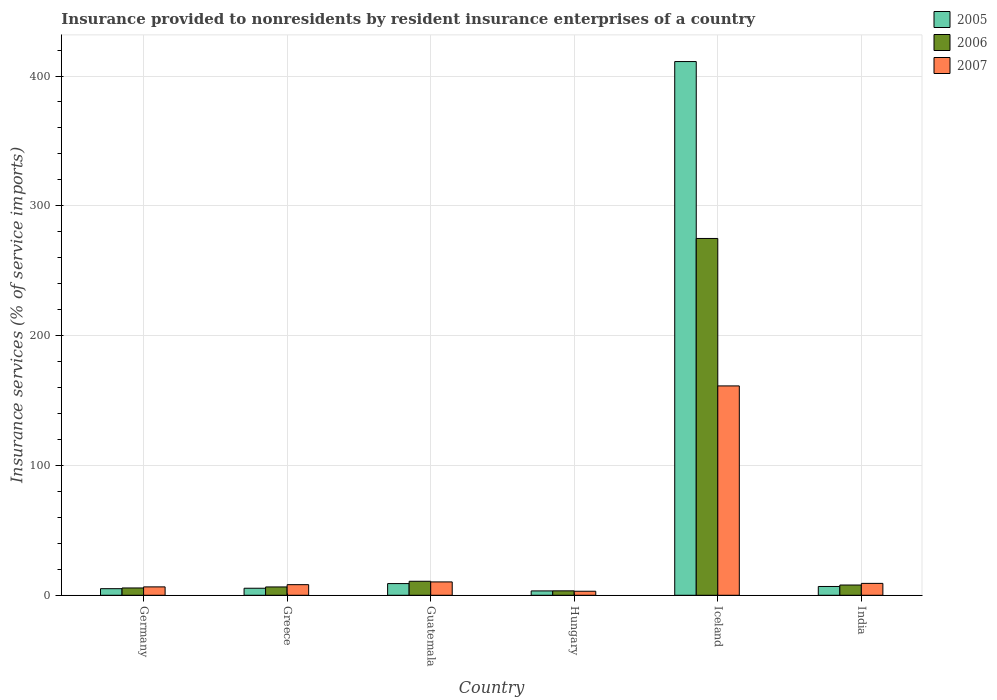Are the number of bars on each tick of the X-axis equal?
Ensure brevity in your answer.  Yes. In how many cases, is the number of bars for a given country not equal to the number of legend labels?
Your response must be concise. 0. What is the insurance provided to nonresidents in 2007 in Guatemala?
Keep it short and to the point. 10.29. Across all countries, what is the maximum insurance provided to nonresidents in 2007?
Provide a short and direct response. 161.27. Across all countries, what is the minimum insurance provided to nonresidents in 2006?
Offer a terse response. 3.4. In which country was the insurance provided to nonresidents in 2006 maximum?
Keep it short and to the point. Iceland. In which country was the insurance provided to nonresidents in 2005 minimum?
Provide a short and direct response. Hungary. What is the total insurance provided to nonresidents in 2005 in the graph?
Your answer should be very brief. 440.79. What is the difference between the insurance provided to nonresidents in 2007 in Greece and that in Iceland?
Make the answer very short. -153.1. What is the difference between the insurance provided to nonresidents in 2005 in India and the insurance provided to nonresidents in 2006 in Greece?
Your answer should be compact. 0.36. What is the average insurance provided to nonresidents in 2007 per country?
Offer a terse response. 33.08. What is the difference between the insurance provided to nonresidents of/in 2005 and insurance provided to nonresidents of/in 2006 in Guatemala?
Offer a very short reply. -1.78. What is the ratio of the insurance provided to nonresidents in 2006 in Iceland to that in India?
Your response must be concise. 34.8. What is the difference between the highest and the second highest insurance provided to nonresidents in 2006?
Your response must be concise. 264.08. What is the difference between the highest and the lowest insurance provided to nonresidents in 2007?
Ensure brevity in your answer.  158.16. In how many countries, is the insurance provided to nonresidents in 2006 greater than the average insurance provided to nonresidents in 2006 taken over all countries?
Offer a very short reply. 1. Is the sum of the insurance provided to nonresidents in 2005 in Iceland and India greater than the maximum insurance provided to nonresidents in 2007 across all countries?
Offer a very short reply. Yes. What does the 3rd bar from the left in Greece represents?
Your answer should be very brief. 2007. Is it the case that in every country, the sum of the insurance provided to nonresidents in 2006 and insurance provided to nonresidents in 2005 is greater than the insurance provided to nonresidents in 2007?
Provide a succinct answer. Yes. How many bars are there?
Your answer should be compact. 18. How many countries are there in the graph?
Keep it short and to the point. 6. Are the values on the major ticks of Y-axis written in scientific E-notation?
Offer a terse response. No. Does the graph contain grids?
Ensure brevity in your answer.  Yes. Where does the legend appear in the graph?
Offer a very short reply. Top right. How many legend labels are there?
Give a very brief answer. 3. What is the title of the graph?
Give a very brief answer. Insurance provided to nonresidents by resident insurance enterprises of a country. Does "1999" appear as one of the legend labels in the graph?
Give a very brief answer. No. What is the label or title of the X-axis?
Offer a terse response. Country. What is the label or title of the Y-axis?
Provide a succinct answer. Insurance services (% of service imports). What is the Insurance services (% of service imports) in 2005 in Germany?
Make the answer very short. 5.08. What is the Insurance services (% of service imports) of 2006 in Germany?
Offer a terse response. 5.63. What is the Insurance services (% of service imports) of 2007 in Germany?
Give a very brief answer. 6.47. What is the Insurance services (% of service imports) of 2005 in Greece?
Provide a succinct answer. 5.42. What is the Insurance services (% of service imports) in 2006 in Greece?
Give a very brief answer. 6.42. What is the Insurance services (% of service imports) in 2007 in Greece?
Your response must be concise. 8.17. What is the Insurance services (% of service imports) in 2005 in Guatemala?
Ensure brevity in your answer.  9.01. What is the Insurance services (% of service imports) in 2006 in Guatemala?
Give a very brief answer. 10.78. What is the Insurance services (% of service imports) of 2007 in Guatemala?
Offer a very short reply. 10.29. What is the Insurance services (% of service imports) of 2005 in Hungary?
Your response must be concise. 3.36. What is the Insurance services (% of service imports) of 2006 in Hungary?
Keep it short and to the point. 3.4. What is the Insurance services (% of service imports) in 2007 in Hungary?
Your response must be concise. 3.11. What is the Insurance services (% of service imports) of 2005 in Iceland?
Your answer should be compact. 411.14. What is the Insurance services (% of service imports) in 2006 in Iceland?
Your answer should be compact. 274.86. What is the Insurance services (% of service imports) in 2007 in Iceland?
Keep it short and to the point. 161.27. What is the Insurance services (% of service imports) in 2005 in India?
Your response must be concise. 6.78. What is the Insurance services (% of service imports) in 2006 in India?
Your answer should be very brief. 7.9. What is the Insurance services (% of service imports) of 2007 in India?
Keep it short and to the point. 9.16. Across all countries, what is the maximum Insurance services (% of service imports) of 2005?
Give a very brief answer. 411.14. Across all countries, what is the maximum Insurance services (% of service imports) in 2006?
Provide a short and direct response. 274.86. Across all countries, what is the maximum Insurance services (% of service imports) of 2007?
Offer a terse response. 161.27. Across all countries, what is the minimum Insurance services (% of service imports) in 2005?
Your response must be concise. 3.36. Across all countries, what is the minimum Insurance services (% of service imports) of 2006?
Provide a succinct answer. 3.4. Across all countries, what is the minimum Insurance services (% of service imports) in 2007?
Make the answer very short. 3.11. What is the total Insurance services (% of service imports) in 2005 in the graph?
Ensure brevity in your answer.  440.79. What is the total Insurance services (% of service imports) in 2006 in the graph?
Ensure brevity in your answer.  309. What is the total Insurance services (% of service imports) of 2007 in the graph?
Keep it short and to the point. 198.47. What is the difference between the Insurance services (% of service imports) in 2005 in Germany and that in Greece?
Give a very brief answer. -0.34. What is the difference between the Insurance services (% of service imports) in 2006 in Germany and that in Greece?
Provide a short and direct response. -0.79. What is the difference between the Insurance services (% of service imports) in 2007 in Germany and that in Greece?
Provide a short and direct response. -1.71. What is the difference between the Insurance services (% of service imports) of 2005 in Germany and that in Guatemala?
Your response must be concise. -3.93. What is the difference between the Insurance services (% of service imports) in 2006 in Germany and that in Guatemala?
Provide a succinct answer. -5.16. What is the difference between the Insurance services (% of service imports) of 2007 in Germany and that in Guatemala?
Offer a very short reply. -3.82. What is the difference between the Insurance services (% of service imports) of 2005 in Germany and that in Hungary?
Keep it short and to the point. 1.72. What is the difference between the Insurance services (% of service imports) of 2006 in Germany and that in Hungary?
Offer a terse response. 2.22. What is the difference between the Insurance services (% of service imports) of 2007 in Germany and that in Hungary?
Offer a very short reply. 3.36. What is the difference between the Insurance services (% of service imports) of 2005 in Germany and that in Iceland?
Provide a succinct answer. -406.05. What is the difference between the Insurance services (% of service imports) of 2006 in Germany and that in Iceland?
Make the answer very short. -269.23. What is the difference between the Insurance services (% of service imports) of 2007 in Germany and that in Iceland?
Your answer should be very brief. -154.8. What is the difference between the Insurance services (% of service imports) of 2005 in Germany and that in India?
Your response must be concise. -1.7. What is the difference between the Insurance services (% of service imports) of 2006 in Germany and that in India?
Your response must be concise. -2.27. What is the difference between the Insurance services (% of service imports) in 2007 in Germany and that in India?
Your answer should be compact. -2.69. What is the difference between the Insurance services (% of service imports) in 2005 in Greece and that in Guatemala?
Offer a terse response. -3.59. What is the difference between the Insurance services (% of service imports) in 2006 in Greece and that in Guatemala?
Provide a succinct answer. -4.36. What is the difference between the Insurance services (% of service imports) in 2007 in Greece and that in Guatemala?
Provide a short and direct response. -2.11. What is the difference between the Insurance services (% of service imports) of 2005 in Greece and that in Hungary?
Your response must be concise. 2.06. What is the difference between the Insurance services (% of service imports) in 2006 in Greece and that in Hungary?
Keep it short and to the point. 3.02. What is the difference between the Insurance services (% of service imports) in 2007 in Greece and that in Hungary?
Offer a very short reply. 5.06. What is the difference between the Insurance services (% of service imports) of 2005 in Greece and that in Iceland?
Your answer should be very brief. -405.72. What is the difference between the Insurance services (% of service imports) in 2006 in Greece and that in Iceland?
Ensure brevity in your answer.  -268.44. What is the difference between the Insurance services (% of service imports) of 2007 in Greece and that in Iceland?
Offer a terse response. -153.1. What is the difference between the Insurance services (% of service imports) in 2005 in Greece and that in India?
Your answer should be compact. -1.36. What is the difference between the Insurance services (% of service imports) in 2006 in Greece and that in India?
Provide a succinct answer. -1.48. What is the difference between the Insurance services (% of service imports) in 2007 in Greece and that in India?
Your answer should be compact. -0.98. What is the difference between the Insurance services (% of service imports) in 2005 in Guatemala and that in Hungary?
Offer a terse response. 5.65. What is the difference between the Insurance services (% of service imports) of 2006 in Guatemala and that in Hungary?
Give a very brief answer. 7.38. What is the difference between the Insurance services (% of service imports) in 2007 in Guatemala and that in Hungary?
Your answer should be compact. 7.18. What is the difference between the Insurance services (% of service imports) of 2005 in Guatemala and that in Iceland?
Give a very brief answer. -402.13. What is the difference between the Insurance services (% of service imports) of 2006 in Guatemala and that in Iceland?
Offer a very short reply. -264.08. What is the difference between the Insurance services (% of service imports) in 2007 in Guatemala and that in Iceland?
Make the answer very short. -150.99. What is the difference between the Insurance services (% of service imports) in 2005 in Guatemala and that in India?
Offer a terse response. 2.23. What is the difference between the Insurance services (% of service imports) in 2006 in Guatemala and that in India?
Provide a short and direct response. 2.89. What is the difference between the Insurance services (% of service imports) in 2007 in Guatemala and that in India?
Your answer should be compact. 1.13. What is the difference between the Insurance services (% of service imports) of 2005 in Hungary and that in Iceland?
Provide a succinct answer. -407.77. What is the difference between the Insurance services (% of service imports) in 2006 in Hungary and that in Iceland?
Ensure brevity in your answer.  -271.46. What is the difference between the Insurance services (% of service imports) of 2007 in Hungary and that in Iceland?
Keep it short and to the point. -158.16. What is the difference between the Insurance services (% of service imports) in 2005 in Hungary and that in India?
Your answer should be compact. -3.42. What is the difference between the Insurance services (% of service imports) in 2006 in Hungary and that in India?
Offer a very short reply. -4.49. What is the difference between the Insurance services (% of service imports) of 2007 in Hungary and that in India?
Ensure brevity in your answer.  -6.05. What is the difference between the Insurance services (% of service imports) in 2005 in Iceland and that in India?
Make the answer very short. 404.35. What is the difference between the Insurance services (% of service imports) of 2006 in Iceland and that in India?
Your answer should be very brief. 266.96. What is the difference between the Insurance services (% of service imports) in 2007 in Iceland and that in India?
Your answer should be compact. 152.12. What is the difference between the Insurance services (% of service imports) of 2005 in Germany and the Insurance services (% of service imports) of 2006 in Greece?
Provide a short and direct response. -1.34. What is the difference between the Insurance services (% of service imports) of 2005 in Germany and the Insurance services (% of service imports) of 2007 in Greece?
Provide a succinct answer. -3.09. What is the difference between the Insurance services (% of service imports) in 2006 in Germany and the Insurance services (% of service imports) in 2007 in Greece?
Keep it short and to the point. -2.54. What is the difference between the Insurance services (% of service imports) of 2005 in Germany and the Insurance services (% of service imports) of 2006 in Guatemala?
Provide a short and direct response. -5.7. What is the difference between the Insurance services (% of service imports) of 2005 in Germany and the Insurance services (% of service imports) of 2007 in Guatemala?
Your answer should be very brief. -5.21. What is the difference between the Insurance services (% of service imports) in 2006 in Germany and the Insurance services (% of service imports) in 2007 in Guatemala?
Your response must be concise. -4.66. What is the difference between the Insurance services (% of service imports) in 2005 in Germany and the Insurance services (% of service imports) in 2006 in Hungary?
Your response must be concise. 1.68. What is the difference between the Insurance services (% of service imports) of 2005 in Germany and the Insurance services (% of service imports) of 2007 in Hungary?
Your response must be concise. 1.97. What is the difference between the Insurance services (% of service imports) of 2006 in Germany and the Insurance services (% of service imports) of 2007 in Hungary?
Provide a short and direct response. 2.52. What is the difference between the Insurance services (% of service imports) of 2005 in Germany and the Insurance services (% of service imports) of 2006 in Iceland?
Keep it short and to the point. -269.78. What is the difference between the Insurance services (% of service imports) of 2005 in Germany and the Insurance services (% of service imports) of 2007 in Iceland?
Offer a terse response. -156.19. What is the difference between the Insurance services (% of service imports) of 2006 in Germany and the Insurance services (% of service imports) of 2007 in Iceland?
Your answer should be compact. -155.64. What is the difference between the Insurance services (% of service imports) of 2005 in Germany and the Insurance services (% of service imports) of 2006 in India?
Keep it short and to the point. -2.81. What is the difference between the Insurance services (% of service imports) in 2005 in Germany and the Insurance services (% of service imports) in 2007 in India?
Your answer should be compact. -4.07. What is the difference between the Insurance services (% of service imports) of 2006 in Germany and the Insurance services (% of service imports) of 2007 in India?
Your response must be concise. -3.53. What is the difference between the Insurance services (% of service imports) in 2005 in Greece and the Insurance services (% of service imports) in 2006 in Guatemala?
Offer a very short reply. -5.37. What is the difference between the Insurance services (% of service imports) in 2005 in Greece and the Insurance services (% of service imports) in 2007 in Guatemala?
Give a very brief answer. -4.87. What is the difference between the Insurance services (% of service imports) in 2006 in Greece and the Insurance services (% of service imports) in 2007 in Guatemala?
Offer a terse response. -3.87. What is the difference between the Insurance services (% of service imports) of 2005 in Greece and the Insurance services (% of service imports) of 2006 in Hungary?
Ensure brevity in your answer.  2.01. What is the difference between the Insurance services (% of service imports) in 2005 in Greece and the Insurance services (% of service imports) in 2007 in Hungary?
Your response must be concise. 2.31. What is the difference between the Insurance services (% of service imports) of 2006 in Greece and the Insurance services (% of service imports) of 2007 in Hungary?
Your response must be concise. 3.31. What is the difference between the Insurance services (% of service imports) of 2005 in Greece and the Insurance services (% of service imports) of 2006 in Iceland?
Your answer should be compact. -269.44. What is the difference between the Insurance services (% of service imports) of 2005 in Greece and the Insurance services (% of service imports) of 2007 in Iceland?
Your answer should be very brief. -155.85. What is the difference between the Insurance services (% of service imports) in 2006 in Greece and the Insurance services (% of service imports) in 2007 in Iceland?
Your response must be concise. -154.85. What is the difference between the Insurance services (% of service imports) of 2005 in Greece and the Insurance services (% of service imports) of 2006 in India?
Offer a very short reply. -2.48. What is the difference between the Insurance services (% of service imports) of 2005 in Greece and the Insurance services (% of service imports) of 2007 in India?
Your answer should be compact. -3.74. What is the difference between the Insurance services (% of service imports) of 2006 in Greece and the Insurance services (% of service imports) of 2007 in India?
Provide a short and direct response. -2.74. What is the difference between the Insurance services (% of service imports) of 2005 in Guatemala and the Insurance services (% of service imports) of 2006 in Hungary?
Your response must be concise. 5.6. What is the difference between the Insurance services (% of service imports) of 2005 in Guatemala and the Insurance services (% of service imports) of 2007 in Hungary?
Provide a succinct answer. 5.9. What is the difference between the Insurance services (% of service imports) in 2006 in Guatemala and the Insurance services (% of service imports) in 2007 in Hungary?
Provide a short and direct response. 7.67. What is the difference between the Insurance services (% of service imports) in 2005 in Guatemala and the Insurance services (% of service imports) in 2006 in Iceland?
Give a very brief answer. -265.85. What is the difference between the Insurance services (% of service imports) of 2005 in Guatemala and the Insurance services (% of service imports) of 2007 in Iceland?
Offer a terse response. -152.26. What is the difference between the Insurance services (% of service imports) in 2006 in Guatemala and the Insurance services (% of service imports) in 2007 in Iceland?
Offer a very short reply. -150.49. What is the difference between the Insurance services (% of service imports) of 2005 in Guatemala and the Insurance services (% of service imports) of 2006 in India?
Your answer should be compact. 1.11. What is the difference between the Insurance services (% of service imports) in 2005 in Guatemala and the Insurance services (% of service imports) in 2007 in India?
Give a very brief answer. -0.15. What is the difference between the Insurance services (% of service imports) in 2006 in Guatemala and the Insurance services (% of service imports) in 2007 in India?
Your answer should be very brief. 1.63. What is the difference between the Insurance services (% of service imports) of 2005 in Hungary and the Insurance services (% of service imports) of 2006 in Iceland?
Provide a succinct answer. -271.5. What is the difference between the Insurance services (% of service imports) in 2005 in Hungary and the Insurance services (% of service imports) in 2007 in Iceland?
Ensure brevity in your answer.  -157.91. What is the difference between the Insurance services (% of service imports) in 2006 in Hungary and the Insurance services (% of service imports) in 2007 in Iceland?
Ensure brevity in your answer.  -157.87. What is the difference between the Insurance services (% of service imports) of 2005 in Hungary and the Insurance services (% of service imports) of 2006 in India?
Provide a succinct answer. -4.54. What is the difference between the Insurance services (% of service imports) of 2005 in Hungary and the Insurance services (% of service imports) of 2007 in India?
Provide a short and direct response. -5.8. What is the difference between the Insurance services (% of service imports) of 2006 in Hungary and the Insurance services (% of service imports) of 2007 in India?
Your answer should be compact. -5.75. What is the difference between the Insurance services (% of service imports) of 2005 in Iceland and the Insurance services (% of service imports) of 2006 in India?
Ensure brevity in your answer.  403.24. What is the difference between the Insurance services (% of service imports) of 2005 in Iceland and the Insurance services (% of service imports) of 2007 in India?
Your response must be concise. 401.98. What is the difference between the Insurance services (% of service imports) of 2006 in Iceland and the Insurance services (% of service imports) of 2007 in India?
Keep it short and to the point. 265.7. What is the average Insurance services (% of service imports) in 2005 per country?
Ensure brevity in your answer.  73.47. What is the average Insurance services (% of service imports) in 2006 per country?
Provide a succinct answer. 51.5. What is the average Insurance services (% of service imports) of 2007 per country?
Your response must be concise. 33.08. What is the difference between the Insurance services (% of service imports) in 2005 and Insurance services (% of service imports) in 2006 in Germany?
Keep it short and to the point. -0.55. What is the difference between the Insurance services (% of service imports) in 2005 and Insurance services (% of service imports) in 2007 in Germany?
Your answer should be very brief. -1.39. What is the difference between the Insurance services (% of service imports) of 2006 and Insurance services (% of service imports) of 2007 in Germany?
Your answer should be compact. -0.84. What is the difference between the Insurance services (% of service imports) in 2005 and Insurance services (% of service imports) in 2006 in Greece?
Your answer should be compact. -1. What is the difference between the Insurance services (% of service imports) in 2005 and Insurance services (% of service imports) in 2007 in Greece?
Your response must be concise. -2.76. What is the difference between the Insurance services (% of service imports) in 2006 and Insurance services (% of service imports) in 2007 in Greece?
Ensure brevity in your answer.  -1.75. What is the difference between the Insurance services (% of service imports) in 2005 and Insurance services (% of service imports) in 2006 in Guatemala?
Make the answer very short. -1.78. What is the difference between the Insurance services (% of service imports) in 2005 and Insurance services (% of service imports) in 2007 in Guatemala?
Your response must be concise. -1.28. What is the difference between the Insurance services (% of service imports) of 2006 and Insurance services (% of service imports) of 2007 in Guatemala?
Your response must be concise. 0.5. What is the difference between the Insurance services (% of service imports) in 2005 and Insurance services (% of service imports) in 2006 in Hungary?
Give a very brief answer. -0.04. What is the difference between the Insurance services (% of service imports) in 2005 and Insurance services (% of service imports) in 2007 in Hungary?
Offer a terse response. 0.25. What is the difference between the Insurance services (% of service imports) of 2006 and Insurance services (% of service imports) of 2007 in Hungary?
Ensure brevity in your answer.  0.29. What is the difference between the Insurance services (% of service imports) in 2005 and Insurance services (% of service imports) in 2006 in Iceland?
Your response must be concise. 136.27. What is the difference between the Insurance services (% of service imports) in 2005 and Insurance services (% of service imports) in 2007 in Iceland?
Offer a terse response. 249.86. What is the difference between the Insurance services (% of service imports) in 2006 and Insurance services (% of service imports) in 2007 in Iceland?
Make the answer very short. 113.59. What is the difference between the Insurance services (% of service imports) in 2005 and Insurance services (% of service imports) in 2006 in India?
Keep it short and to the point. -1.11. What is the difference between the Insurance services (% of service imports) of 2005 and Insurance services (% of service imports) of 2007 in India?
Keep it short and to the point. -2.37. What is the difference between the Insurance services (% of service imports) in 2006 and Insurance services (% of service imports) in 2007 in India?
Your answer should be compact. -1.26. What is the ratio of the Insurance services (% of service imports) of 2005 in Germany to that in Greece?
Offer a terse response. 0.94. What is the ratio of the Insurance services (% of service imports) of 2006 in Germany to that in Greece?
Provide a short and direct response. 0.88. What is the ratio of the Insurance services (% of service imports) in 2007 in Germany to that in Greece?
Provide a short and direct response. 0.79. What is the ratio of the Insurance services (% of service imports) of 2005 in Germany to that in Guatemala?
Provide a short and direct response. 0.56. What is the ratio of the Insurance services (% of service imports) in 2006 in Germany to that in Guatemala?
Provide a succinct answer. 0.52. What is the ratio of the Insurance services (% of service imports) of 2007 in Germany to that in Guatemala?
Provide a succinct answer. 0.63. What is the ratio of the Insurance services (% of service imports) in 2005 in Germany to that in Hungary?
Provide a short and direct response. 1.51. What is the ratio of the Insurance services (% of service imports) of 2006 in Germany to that in Hungary?
Provide a short and direct response. 1.65. What is the ratio of the Insurance services (% of service imports) in 2007 in Germany to that in Hungary?
Ensure brevity in your answer.  2.08. What is the ratio of the Insurance services (% of service imports) in 2005 in Germany to that in Iceland?
Your answer should be compact. 0.01. What is the ratio of the Insurance services (% of service imports) in 2006 in Germany to that in Iceland?
Offer a terse response. 0.02. What is the ratio of the Insurance services (% of service imports) in 2007 in Germany to that in Iceland?
Provide a succinct answer. 0.04. What is the ratio of the Insurance services (% of service imports) in 2005 in Germany to that in India?
Ensure brevity in your answer.  0.75. What is the ratio of the Insurance services (% of service imports) in 2006 in Germany to that in India?
Ensure brevity in your answer.  0.71. What is the ratio of the Insurance services (% of service imports) in 2007 in Germany to that in India?
Provide a short and direct response. 0.71. What is the ratio of the Insurance services (% of service imports) of 2005 in Greece to that in Guatemala?
Provide a succinct answer. 0.6. What is the ratio of the Insurance services (% of service imports) in 2006 in Greece to that in Guatemala?
Give a very brief answer. 0.6. What is the ratio of the Insurance services (% of service imports) of 2007 in Greece to that in Guatemala?
Your response must be concise. 0.79. What is the ratio of the Insurance services (% of service imports) of 2005 in Greece to that in Hungary?
Your answer should be compact. 1.61. What is the ratio of the Insurance services (% of service imports) of 2006 in Greece to that in Hungary?
Ensure brevity in your answer.  1.89. What is the ratio of the Insurance services (% of service imports) in 2007 in Greece to that in Hungary?
Offer a very short reply. 2.63. What is the ratio of the Insurance services (% of service imports) in 2005 in Greece to that in Iceland?
Your answer should be compact. 0.01. What is the ratio of the Insurance services (% of service imports) in 2006 in Greece to that in Iceland?
Provide a short and direct response. 0.02. What is the ratio of the Insurance services (% of service imports) in 2007 in Greece to that in Iceland?
Offer a terse response. 0.05. What is the ratio of the Insurance services (% of service imports) in 2005 in Greece to that in India?
Ensure brevity in your answer.  0.8. What is the ratio of the Insurance services (% of service imports) in 2006 in Greece to that in India?
Ensure brevity in your answer.  0.81. What is the ratio of the Insurance services (% of service imports) in 2007 in Greece to that in India?
Your answer should be very brief. 0.89. What is the ratio of the Insurance services (% of service imports) of 2005 in Guatemala to that in Hungary?
Offer a very short reply. 2.68. What is the ratio of the Insurance services (% of service imports) of 2006 in Guatemala to that in Hungary?
Your answer should be compact. 3.17. What is the ratio of the Insurance services (% of service imports) in 2007 in Guatemala to that in Hungary?
Provide a short and direct response. 3.31. What is the ratio of the Insurance services (% of service imports) of 2005 in Guatemala to that in Iceland?
Offer a very short reply. 0.02. What is the ratio of the Insurance services (% of service imports) in 2006 in Guatemala to that in Iceland?
Your response must be concise. 0.04. What is the ratio of the Insurance services (% of service imports) of 2007 in Guatemala to that in Iceland?
Your response must be concise. 0.06. What is the ratio of the Insurance services (% of service imports) in 2005 in Guatemala to that in India?
Offer a terse response. 1.33. What is the ratio of the Insurance services (% of service imports) in 2006 in Guatemala to that in India?
Your answer should be compact. 1.37. What is the ratio of the Insurance services (% of service imports) in 2007 in Guatemala to that in India?
Offer a very short reply. 1.12. What is the ratio of the Insurance services (% of service imports) of 2005 in Hungary to that in Iceland?
Give a very brief answer. 0.01. What is the ratio of the Insurance services (% of service imports) of 2006 in Hungary to that in Iceland?
Your answer should be compact. 0.01. What is the ratio of the Insurance services (% of service imports) of 2007 in Hungary to that in Iceland?
Your answer should be very brief. 0.02. What is the ratio of the Insurance services (% of service imports) of 2005 in Hungary to that in India?
Keep it short and to the point. 0.5. What is the ratio of the Insurance services (% of service imports) of 2006 in Hungary to that in India?
Your response must be concise. 0.43. What is the ratio of the Insurance services (% of service imports) of 2007 in Hungary to that in India?
Provide a succinct answer. 0.34. What is the ratio of the Insurance services (% of service imports) in 2005 in Iceland to that in India?
Offer a very short reply. 60.62. What is the ratio of the Insurance services (% of service imports) of 2006 in Iceland to that in India?
Provide a succinct answer. 34.8. What is the ratio of the Insurance services (% of service imports) in 2007 in Iceland to that in India?
Make the answer very short. 17.61. What is the difference between the highest and the second highest Insurance services (% of service imports) in 2005?
Keep it short and to the point. 402.13. What is the difference between the highest and the second highest Insurance services (% of service imports) in 2006?
Offer a very short reply. 264.08. What is the difference between the highest and the second highest Insurance services (% of service imports) of 2007?
Offer a very short reply. 150.99. What is the difference between the highest and the lowest Insurance services (% of service imports) of 2005?
Give a very brief answer. 407.77. What is the difference between the highest and the lowest Insurance services (% of service imports) of 2006?
Your response must be concise. 271.46. What is the difference between the highest and the lowest Insurance services (% of service imports) in 2007?
Give a very brief answer. 158.16. 